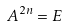Convert formula to latex. <formula><loc_0><loc_0><loc_500><loc_500>A ^ { 2 n } = E</formula> 